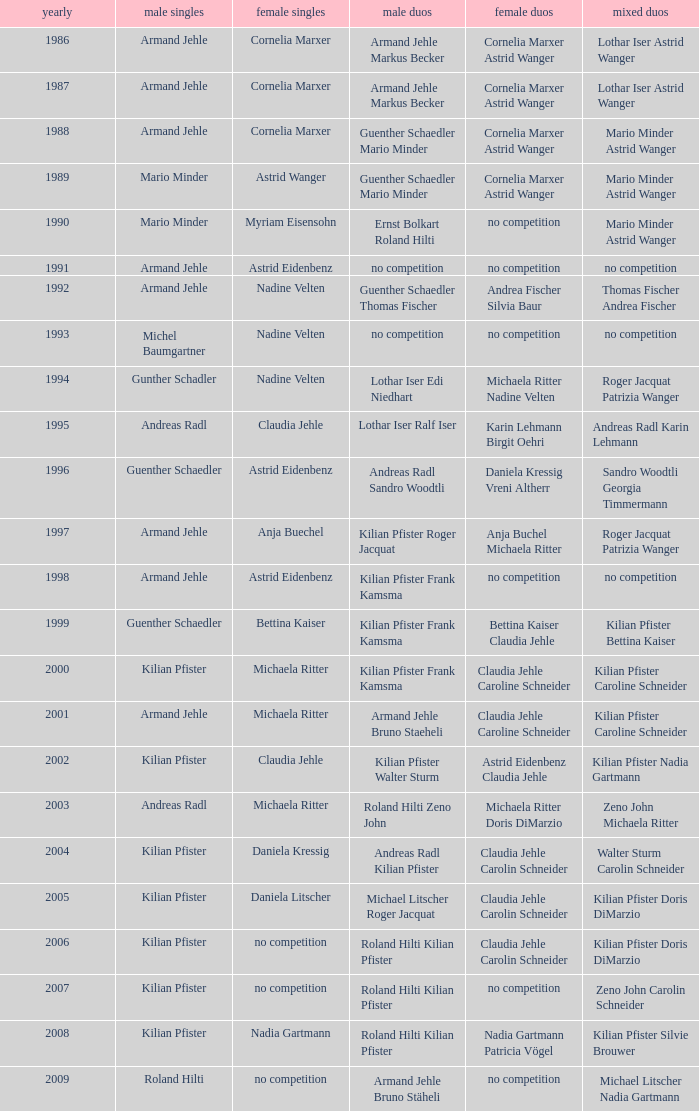In 2001, where the mens singles is armand jehle and the womens singles is michaela ritter, who are the mixed doubles Kilian Pfister Caroline Schneider. 